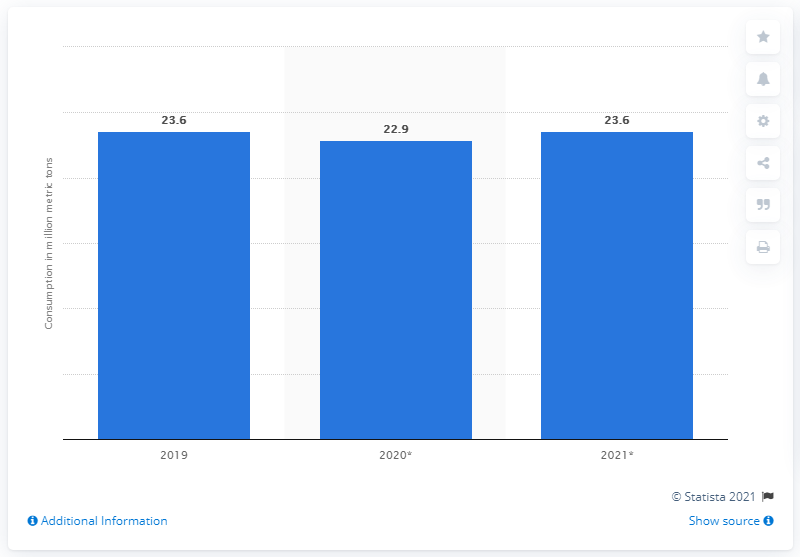Outline some significant characteristics in this image. In 2019, the global demand for copper was 23.6%. 